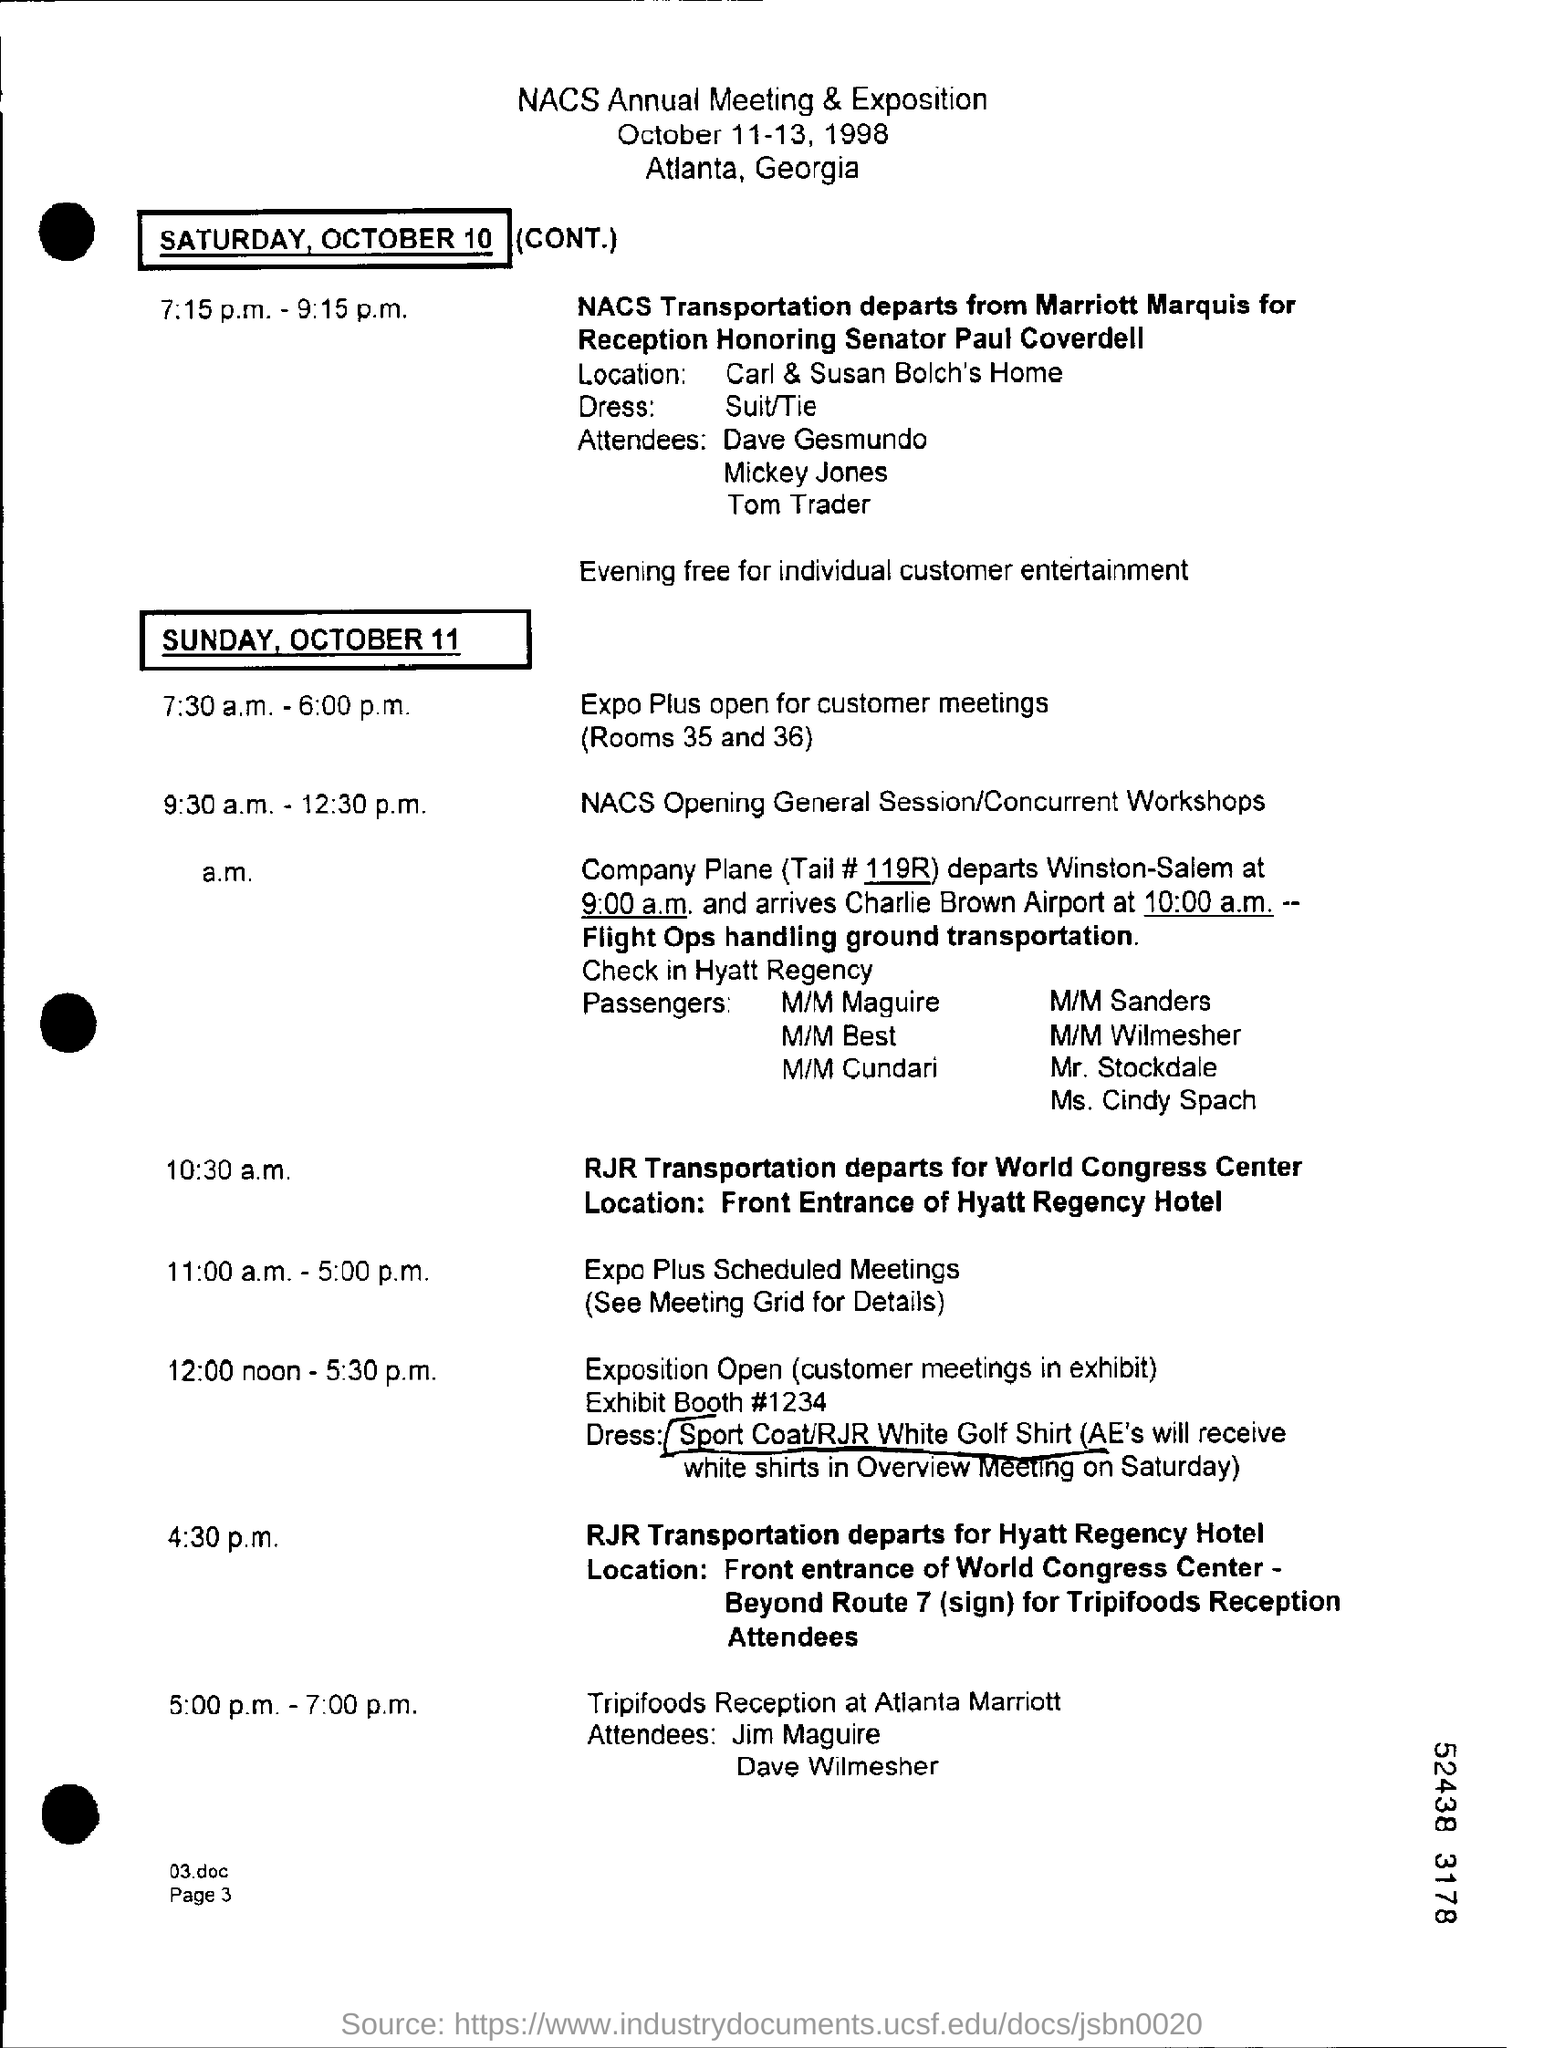What rooms are scheduled for expo plus open for customers meetings ?
Offer a very short reply. Rooms 35 and 36. What is the tail #?
Keep it short and to the point. 119R. When is the date nacs annual meeting & exposition on ?
Offer a terse response. October 11-13, 1998. Where is the nacs annual meeting & exposition at ?
Provide a short and direct response. Atlanta, Georgia. What is the exhibit booth #?
Provide a succinct answer. 1234. 